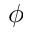Convert formula to latex. <formula><loc_0><loc_0><loc_500><loc_500>\phi</formula> 